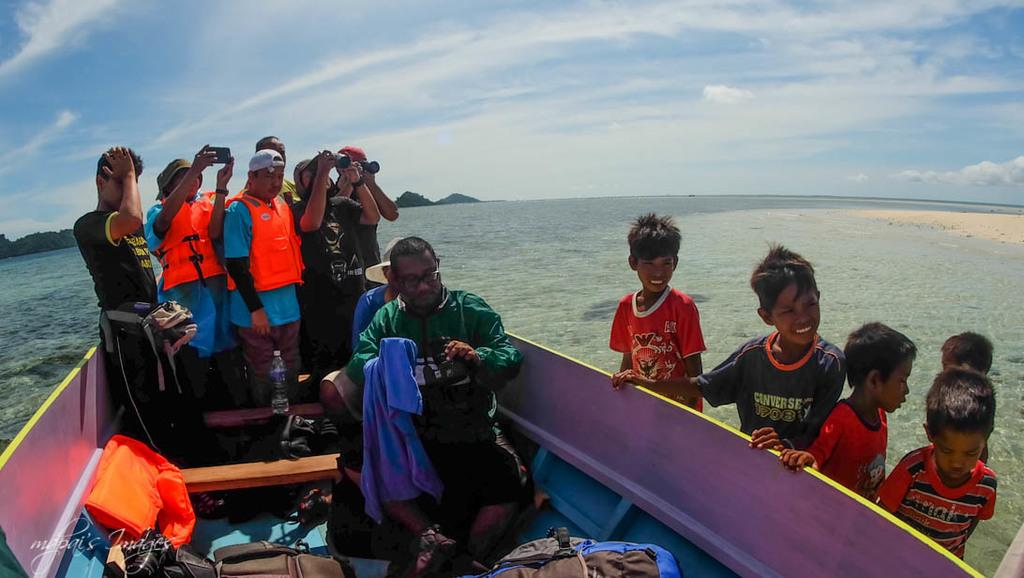Who or what can be seen in the image? There are people in the image. What is the people using or riding in the image? There is a boat in the image. What is the natural environment like in the image? There is water and sky visible in the image, with clouds in the sky. What type of vegetation is visible in the background of the image? There are trees in the background of the image. What type of shoe is being used to paddle the boat in the image? There is no shoe present in the image, and the people are not using a shoe to paddle the boat. 